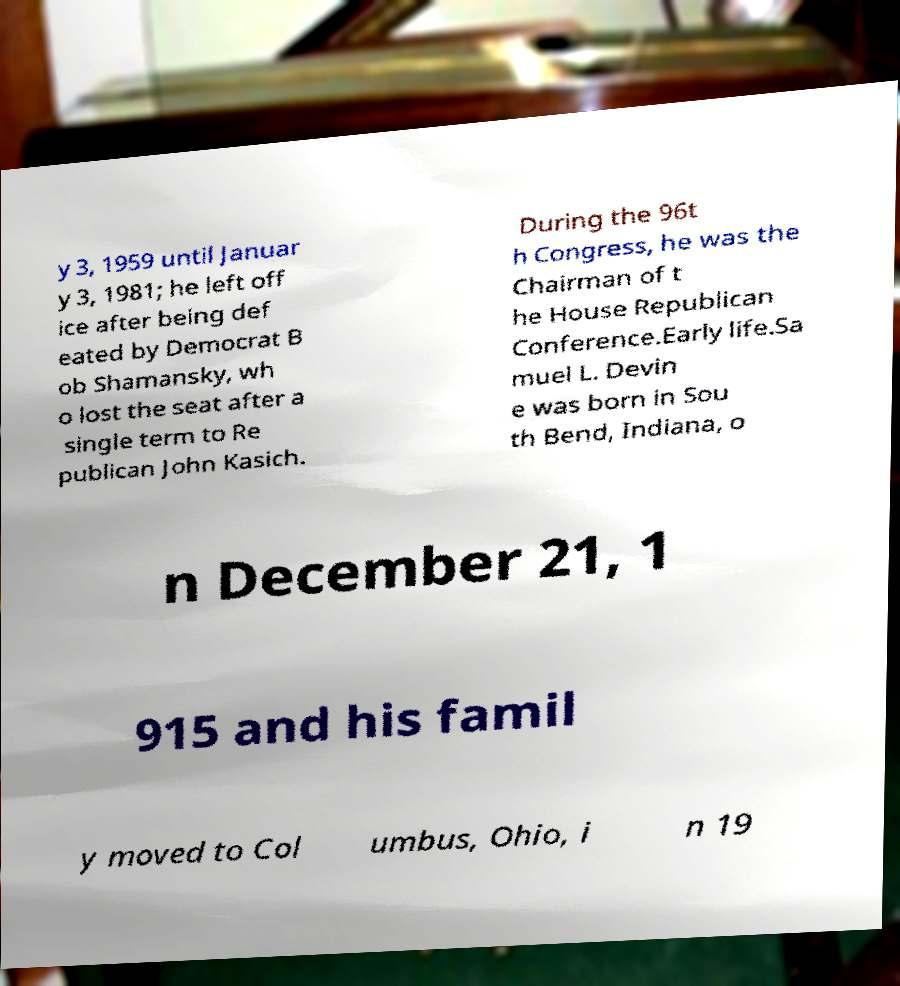For documentation purposes, I need the text within this image transcribed. Could you provide that? y 3, 1959 until Januar y 3, 1981; he left off ice after being def eated by Democrat B ob Shamansky, wh o lost the seat after a single term to Re publican John Kasich. During the 96t h Congress, he was the Chairman of t he House Republican Conference.Early life.Sa muel L. Devin e was born in Sou th Bend, Indiana, o n December 21, 1 915 and his famil y moved to Col umbus, Ohio, i n 19 